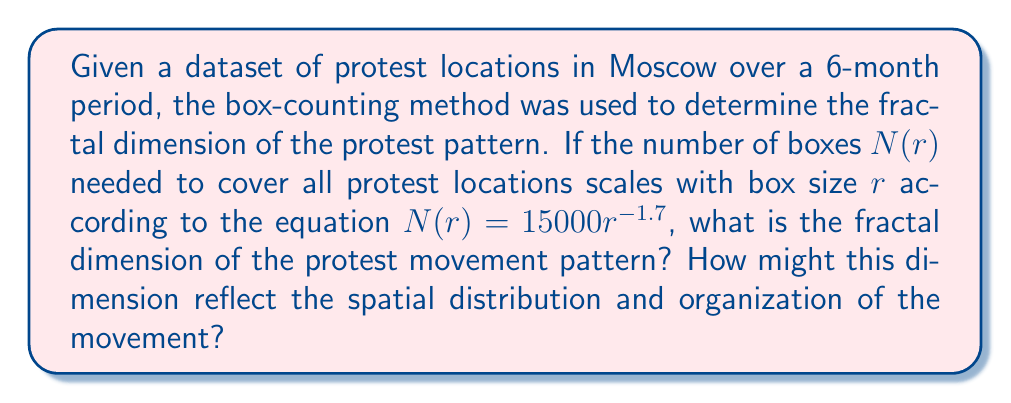Help me with this question. To determine the fractal dimension using the box-counting method, we follow these steps:

1. Recall the box-counting dimension formula:
   $$D = -\lim_{r \to 0} \frac{\log N(r)}{\log r}$$

2. In our case, we have $N(r) = 15000r^{-1.7}$

3. Take the logarithm of both sides:
   $$\log N(r) = \log(15000) + \log(r^{-1.7})$$

4. Using the properties of logarithms:
   $$\log N(r) = \log(15000) - 1.7 \log(r)$$

5. Rearrange to match the form of the box-counting dimension formula:
   $$-\frac{\log N(r)}{\log r} = 1.7 - \frac{\log(15000)}{\log r}$$

6. As $r \to 0$, $\log r \to -\infty$, so $\frac{\log(15000)}{\log r} \to 0$

7. Therefore, the limit as $r \to 0$ is:
   $$D = \lim_{r \to 0} -\frac{\log N(r)}{\log r} = 1.7$$

The fractal dimension of 1.7 suggests that the protest movement pattern is more spread out than a simple line (dimension 1) but doesn't completely fill the 2D space. This indicates a moderately complex spatial distribution, potentially reflecting:

1. A semi-organized movement with some central coordination
2. Clustering around key locations (e.g., government buildings) with some spread to other areas
3. A balance between concentrated and dispersed protest activities
Answer: 1.7 